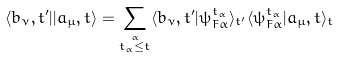<formula> <loc_0><loc_0><loc_500><loc_500>\langle b _ { \nu } , t ^ { \prime } | | a _ { \mu } , t \rangle = \sum _ { \stackrel { \alpha } { t _ { \alpha } \leq t } } \langle b _ { \nu } , t ^ { \prime } | \psi ^ { t _ { \alpha } } _ { F \alpha } \rangle _ { t ^ { \prime } } \langle \psi ^ { t _ { \alpha } } _ { F \alpha } | a _ { \mu } , t \rangle _ { t }</formula> 